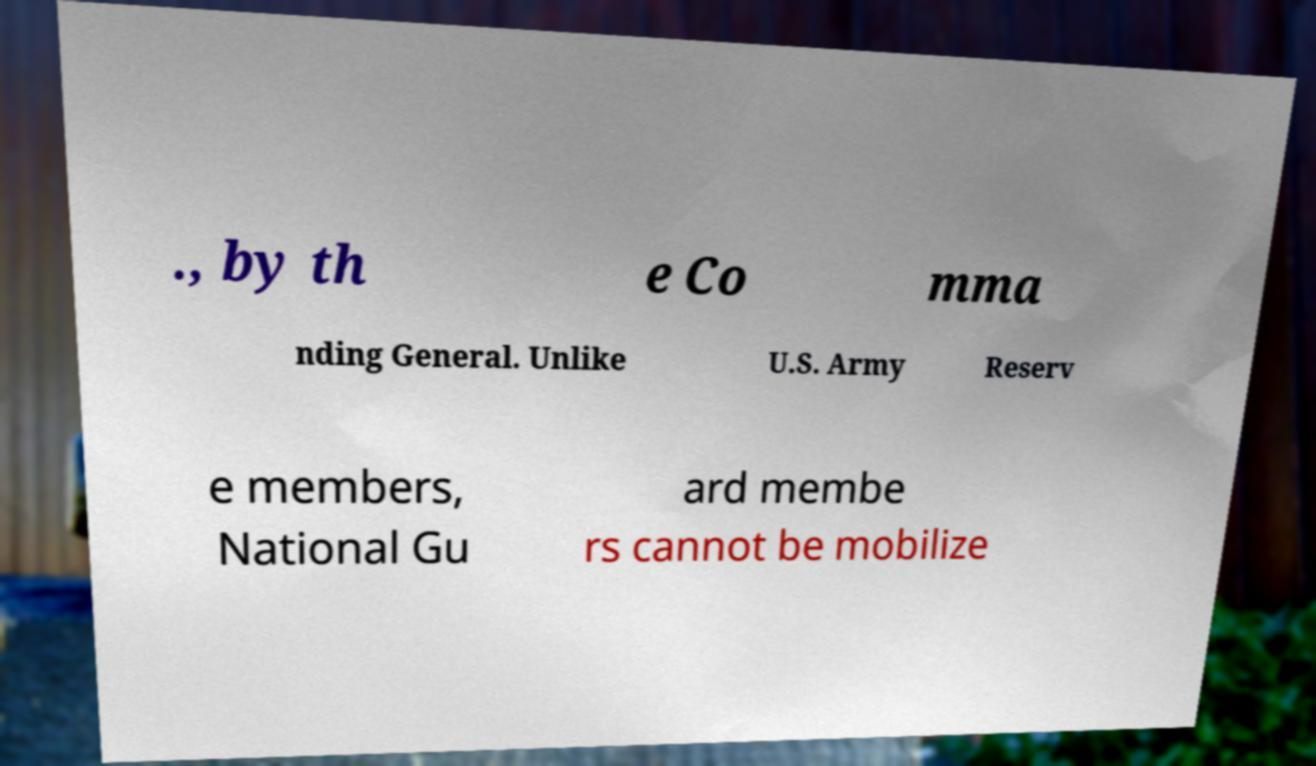Could you assist in decoding the text presented in this image and type it out clearly? ., by th e Co mma nding General. Unlike U.S. Army Reserv e members, National Gu ard membe rs cannot be mobilize 